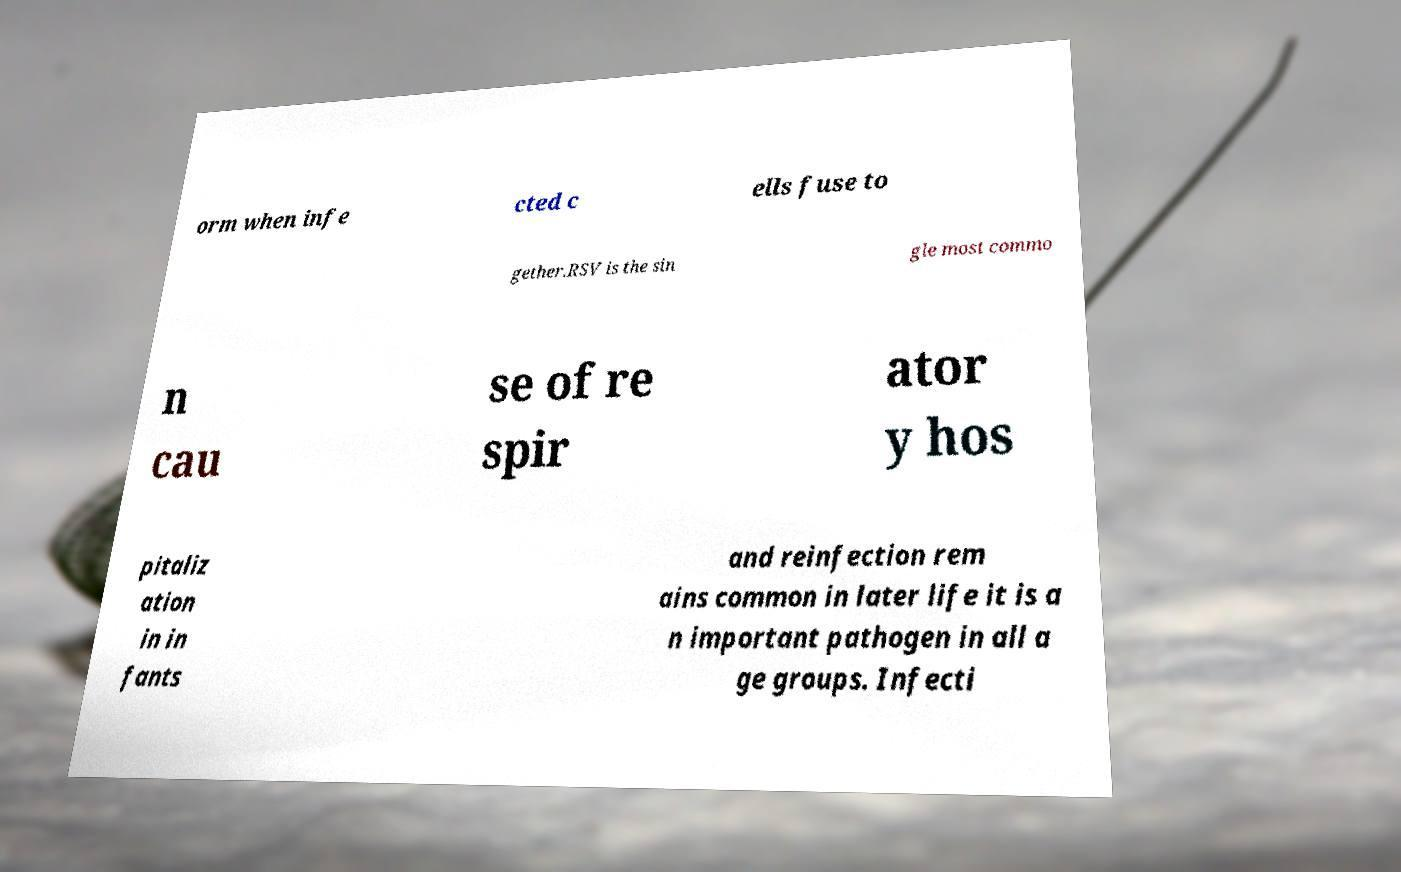Please identify and transcribe the text found in this image. orm when infe cted c ells fuse to gether.RSV is the sin gle most commo n cau se of re spir ator y hos pitaliz ation in in fants and reinfection rem ains common in later life it is a n important pathogen in all a ge groups. Infecti 